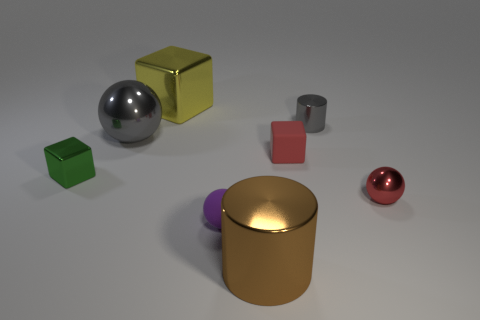Are there any yellow cubes behind the large ball?
Give a very brief answer. Yes. The other thing that is the same shape as the large brown metal object is what color?
Offer a very short reply. Gray. Is there any other thing that is the same shape as the purple thing?
Ensure brevity in your answer.  Yes. There is a object on the right side of the small cylinder; what is its material?
Keep it short and to the point. Metal. The purple matte thing that is the same shape as the red metallic thing is what size?
Ensure brevity in your answer.  Small. How many large brown cylinders have the same material as the purple ball?
Offer a very short reply. 0. How many big objects have the same color as the big metal cylinder?
Your answer should be compact. 0. How many objects are tiny things in front of the matte block or balls that are behind the red cube?
Your answer should be compact. 4. Is the number of small green objects that are on the right side of the small gray cylinder less than the number of yellow metal cylinders?
Provide a succinct answer. No. Are there any green metallic cubes that have the same size as the purple sphere?
Provide a succinct answer. Yes. 